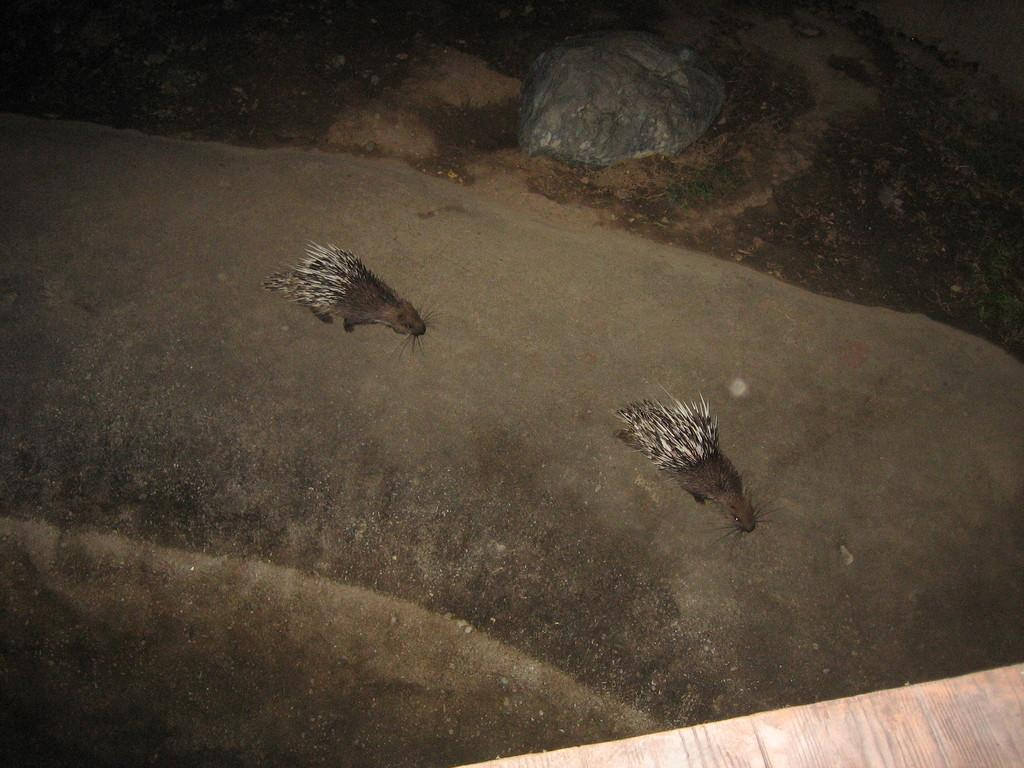What animals are present in the image? There are porcupines in the image. Where are the porcupines located? The porcupines are on the ground. What type of chess pieces can be seen in the image? There are no chess pieces present in the image; it features porcupines on the ground. What type of tools might a carpenter use in the image? There are no carpentry tools present in the image; it features porcupines on the ground. 